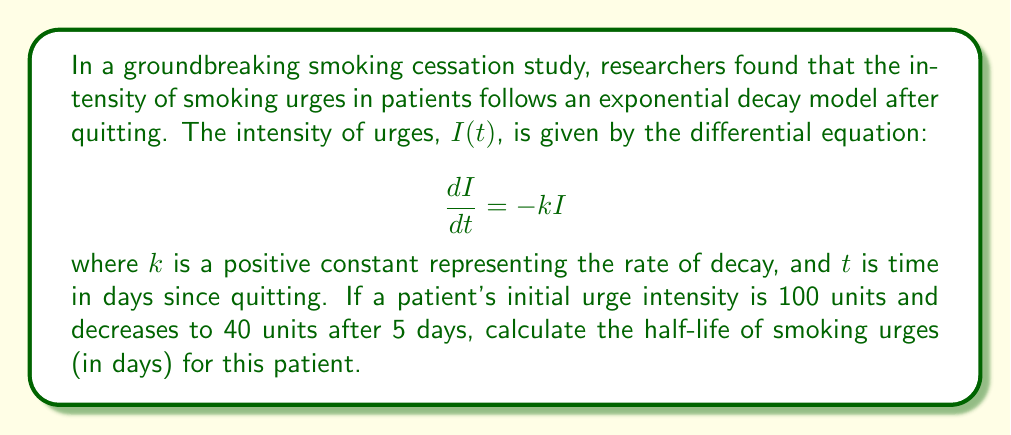Help me with this question. Let's approach this step-by-step:

1) The general solution to the differential equation $\frac{dI}{dt} = -kI$ is:

   $$I(t) = I_0e^{-kt}$$

   where $I_0$ is the initial intensity at $t=0$.

2) We're given that $I_0 = 100$ and $I(5) = 40$. Let's substitute these into our equation:

   $$40 = 100e^{-5k}$$

3) Divide both sides by 100:

   $$0.4 = e^{-5k}$$

4) Take the natural logarithm of both sides:

   $$\ln(0.4) = -5k$$

5) Solve for $k$:

   $$k = -\frac{\ln(0.4)}{5} \approx 0.1832$$

6) The half-life $t_{1/2}$ is the time it takes for the intensity to decrease by half. It satisfies:

   $$\frac{1}{2} = e^{-kt_{1/2}}$$

7) Take the natural logarithm of both sides:

   $$\ln(\frac{1}{2}) = -kt_{1/2}$$

8) Solve for $t_{1/2}$:

   $$t_{1/2} = -\frac{\ln(\frac{1}{2})}{k} = \frac{\ln(2)}{k}$$

9) Substitute the value of $k$ we found:

   $$t_{1/2} = \frac{\ln(2)}{0.1832} \approx 3.7836$$
Answer: The half-life of smoking urges for this patient is approximately 3.78 days. 